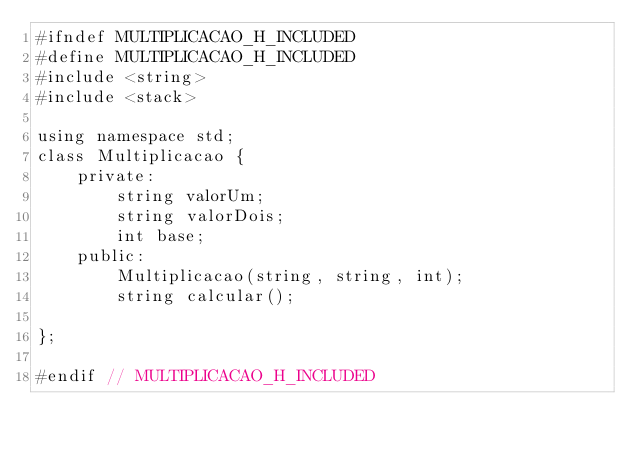Convert code to text. <code><loc_0><loc_0><loc_500><loc_500><_C_>#ifndef MULTIPLICACAO_H_INCLUDED
#define MULTIPLICACAO_H_INCLUDED
#include <string>
#include <stack>

using namespace std;
class Multiplicacao {
    private:
        string valorUm;
        string valorDois;
        int base;
    public:
        Multiplicacao(string, string, int);
        string calcular();

};

#endif // MULTIPLICACAO_H_INCLUDED
</code> 